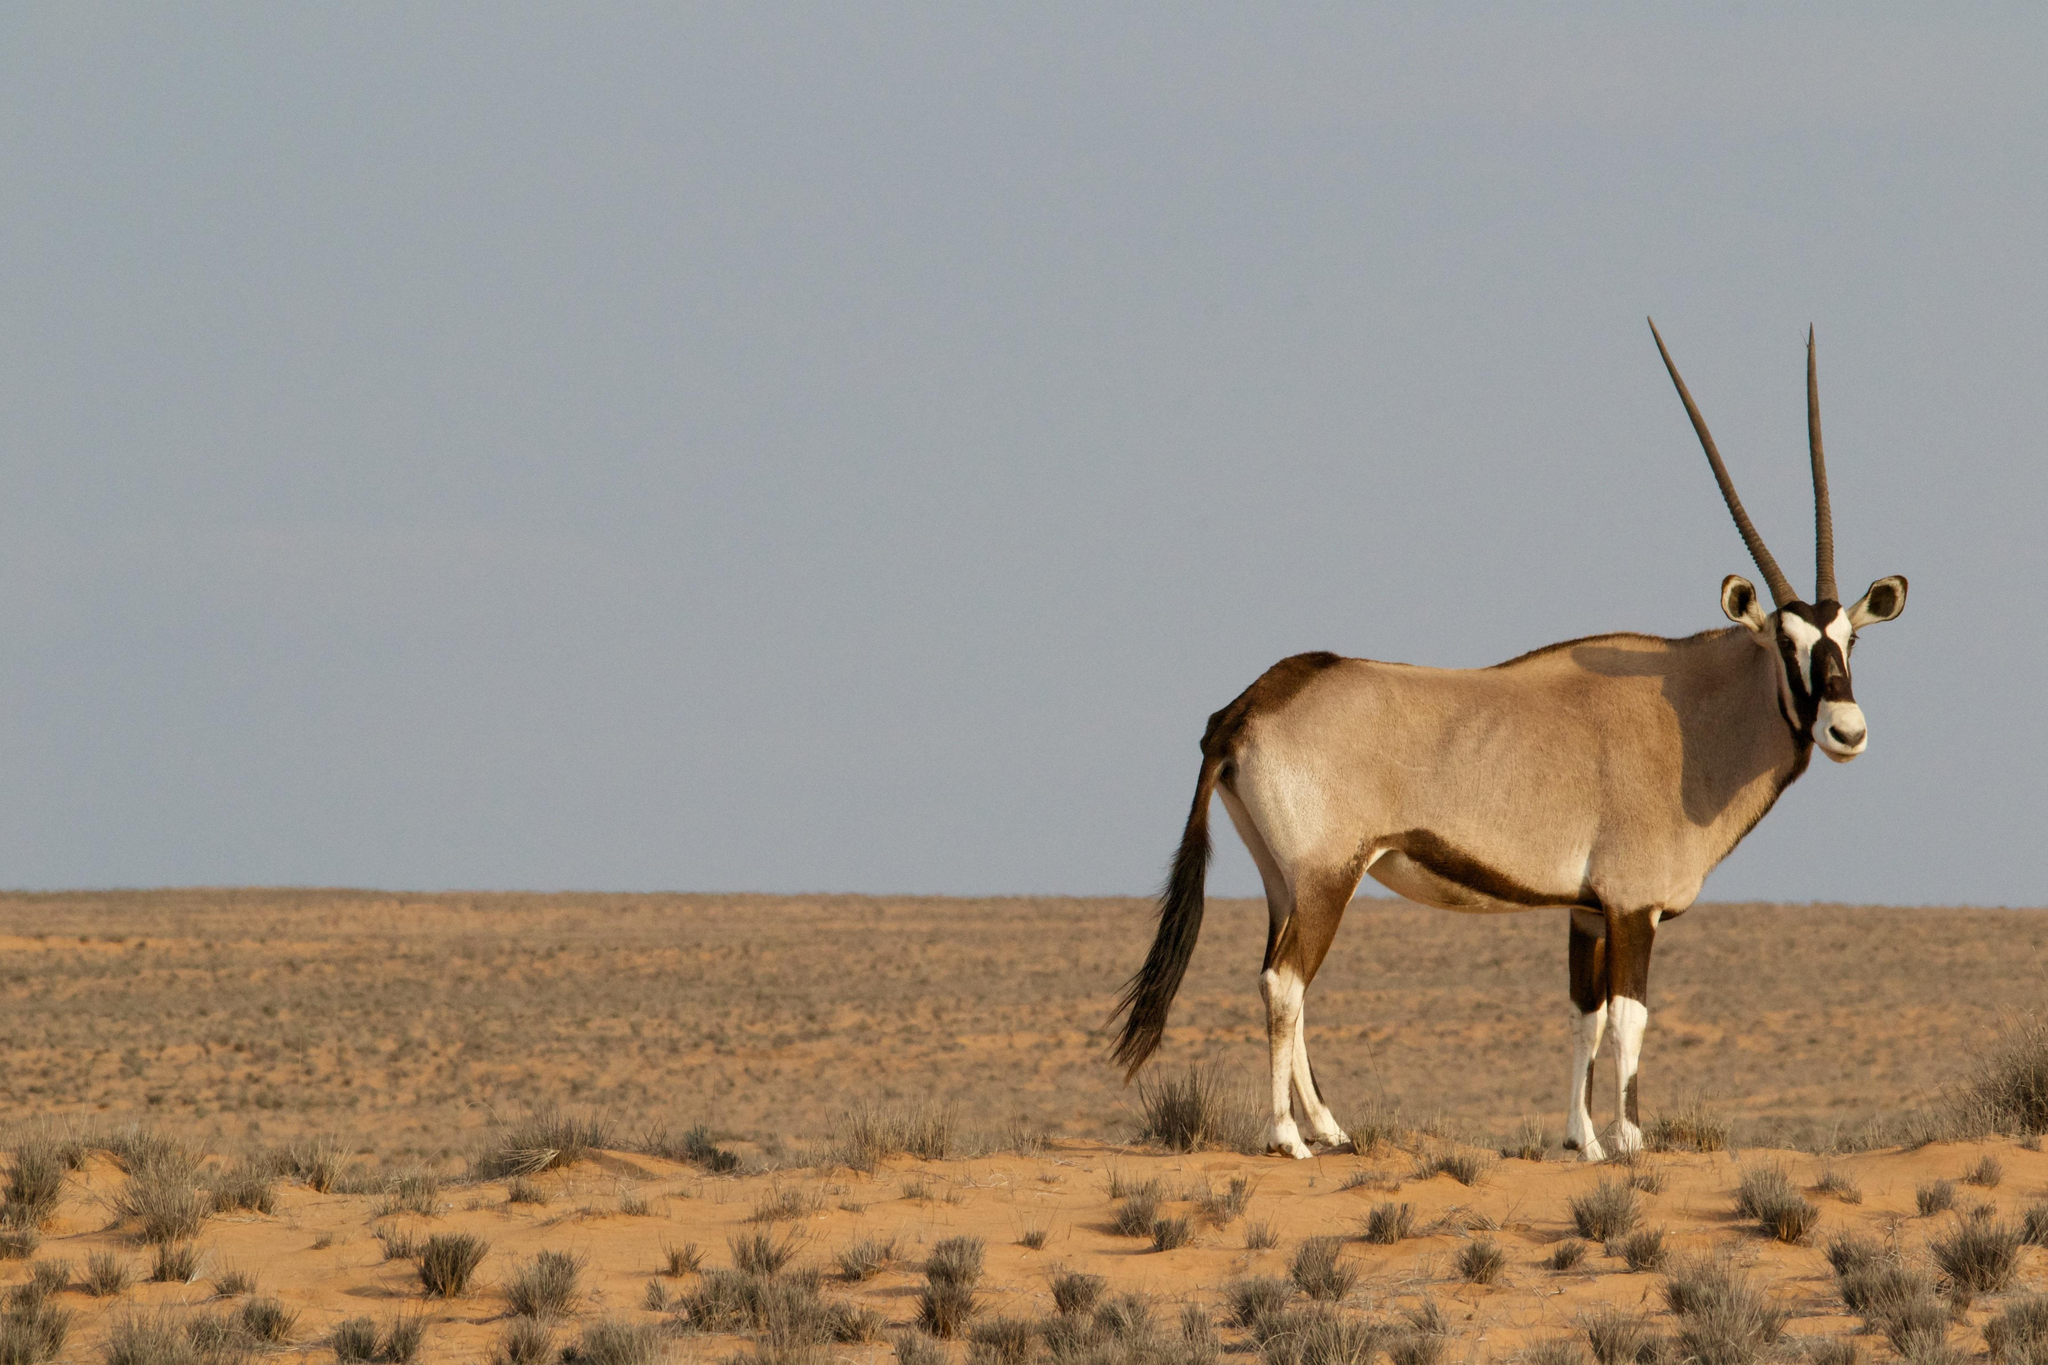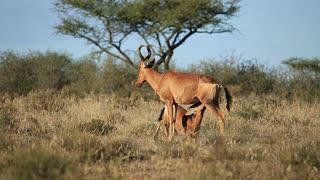The first image is the image on the left, the second image is the image on the right. Considering the images on both sides, is "There are at least four animals in the image on the right." valid? Answer yes or no. No. 